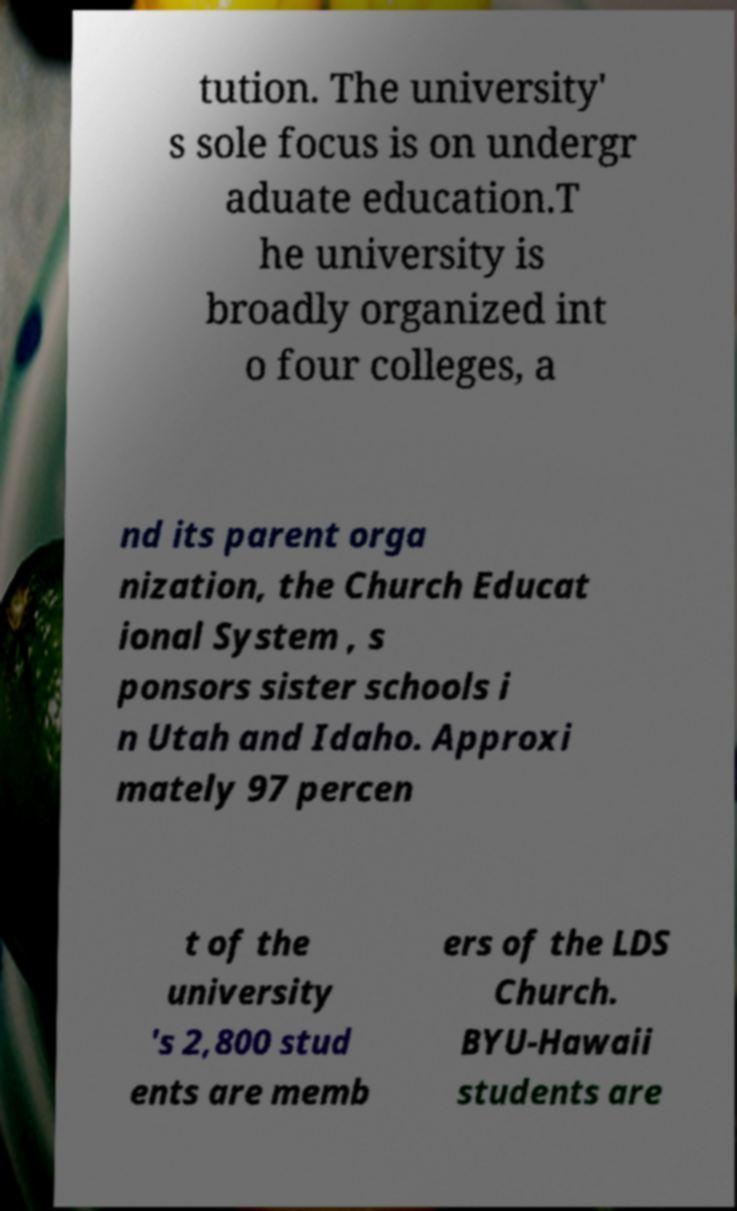Can you read and provide the text displayed in the image?This photo seems to have some interesting text. Can you extract and type it out for me? tution. The university' s sole focus is on undergr aduate education.T he university is broadly organized int o four colleges, a nd its parent orga nization, the Church Educat ional System , s ponsors sister schools i n Utah and Idaho. Approxi mately 97 percen t of the university 's 2,800 stud ents are memb ers of the LDS Church. BYU-Hawaii students are 